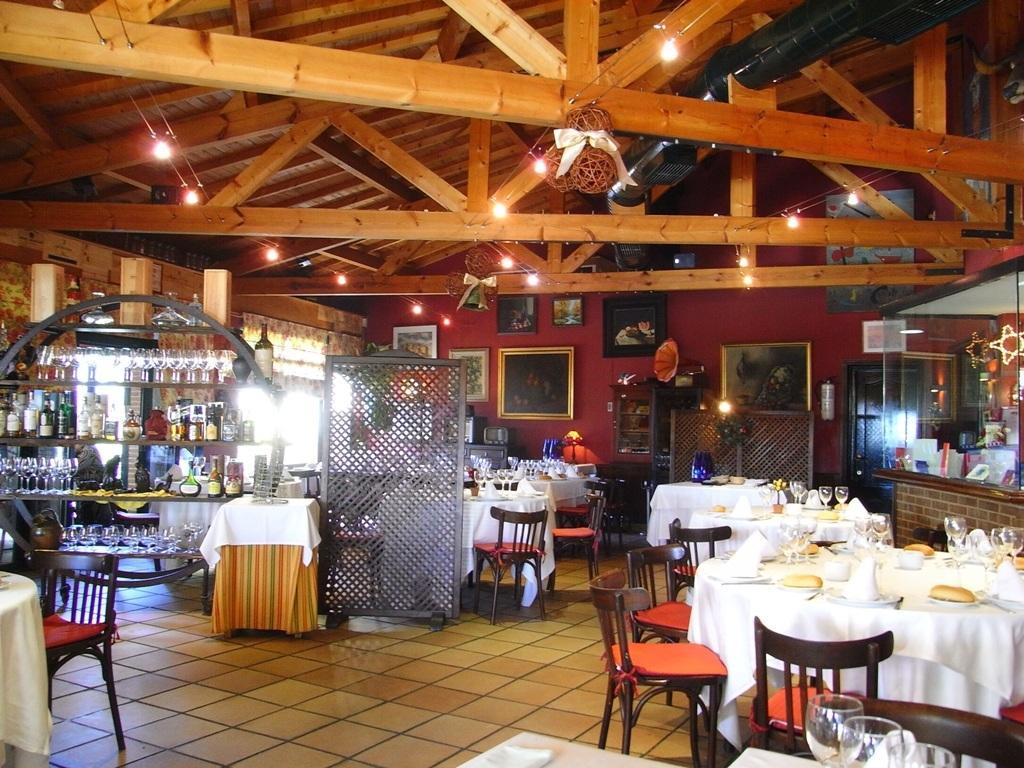Describe this image in one or two sentences. In this image we can see the inside view of the building and there are tables with a cloth, on the table there are glasses, plates, food items and few objects. And at the back we can see the wall with photo frames, beside the wall there are few objects. And there are racks, in that we can see glasses and bottles. There are chairs near the table. At the top we can see the ceiling with lights and a black color object. 